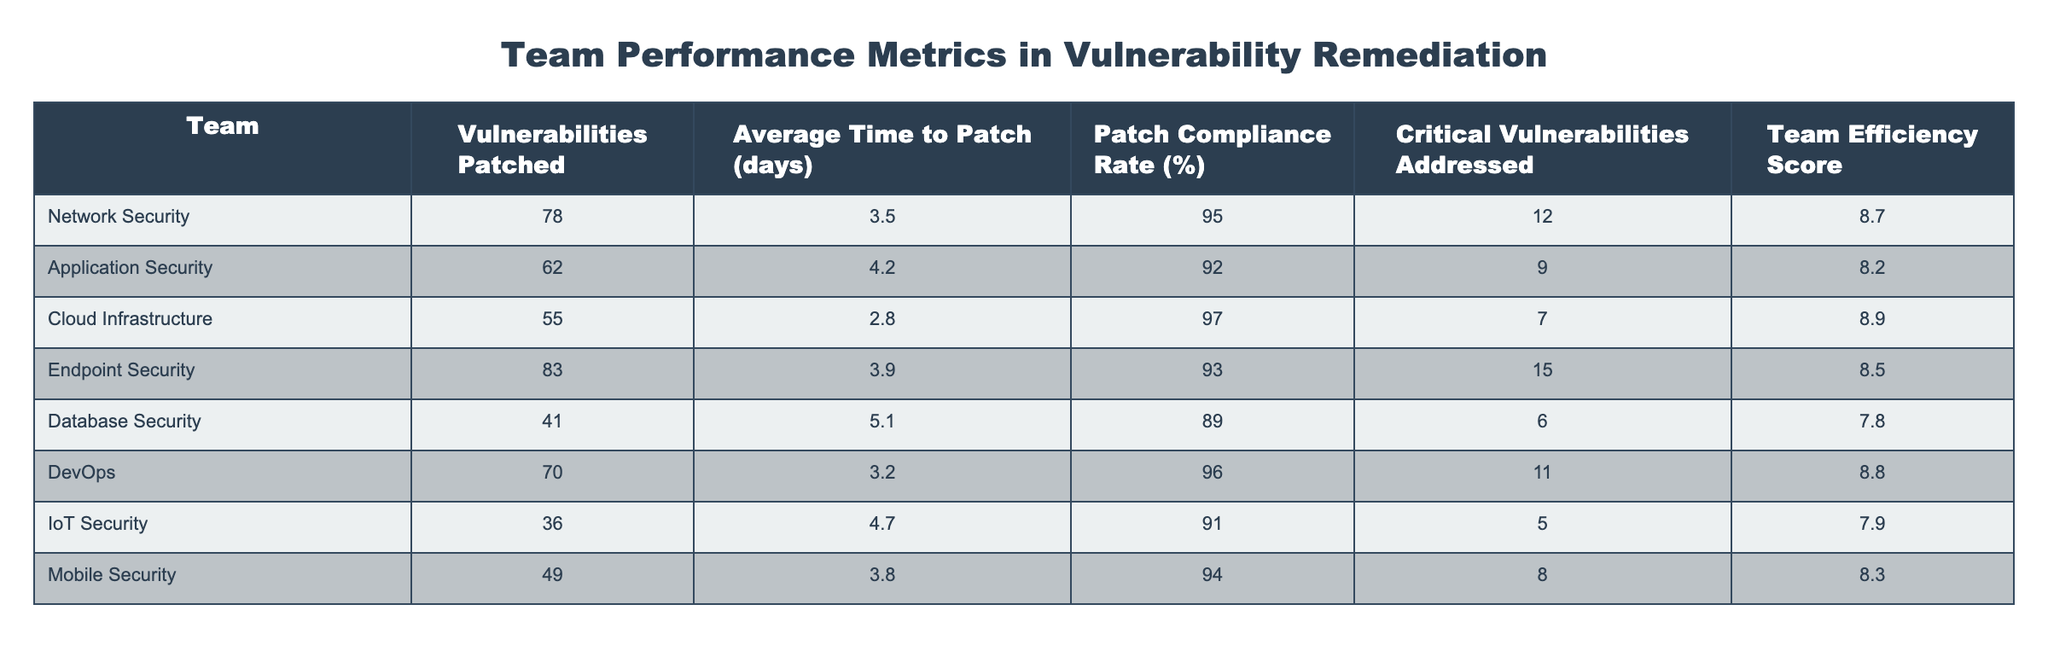What is the highest patch compliance rate among the teams? The highest patch compliance rate can be found by comparing the values in the patch compliance rate column. We find that the Cloud Infrastructure team has a compliance rate of 97%, which is the highest among all teams.
Answer: 97% Which team patched the most vulnerabilities? By examining the vulnerabilities patched column, we see that Endpoint Security patched the most vulnerabilities with a total of 83.
Answer: 83 What is the average time to patch for teams with a patch compliance rate above 90%? First, we identify teams with a compliance rate above 90%. These teams are Network Security, Application Security, Cloud Infrastructure, DevOps, and Endpoint Security. Their average time to patch is (3.5 + 4.2 + 2.8 + 3.2 + 3.9) / 5 = 3.52 days.
Answer: 3.52 days Is the average time to patch for Database Security greater than 4 days? The average time to patch for Database Security is listed as 5.1 days in the table, which is indeed greater than 4 days.
Answer: Yes Which team had the lowest efficiency score, and what was it? Looking at the team efficiency score column, the team with the lowest score is Database Security, which has a score of 7.8.
Answer: 7.8 What is the total number of critical vulnerabilities addressed by all teams? To find the total critical vulnerabilities addressed, we sum the values in the critical vulnerabilities addressed column: 12 + 9 + 7 + 15 + 6 + 11 + 5 + 8 = 73.
Answer: 73 How many vulnerabilities were patched by the Application Security team compared to the Cloud Infrastructure team? The Application Security team patched 62 vulnerabilities, while the Cloud Infrastructure team patched 55. Therefore, Application Security patched 7 more vulnerabilities than Cloud Infrastructure.
Answer: 7 more vulnerabilities Does the Endpoint Security team have a higher efficiency score than the Mobile Security team? Comparing the efficiency scores, Endpoint Security has a score of 8.5, while Mobile Security has a score of 8.3. Endpoint Security's score is higher.
Answer: Yes 